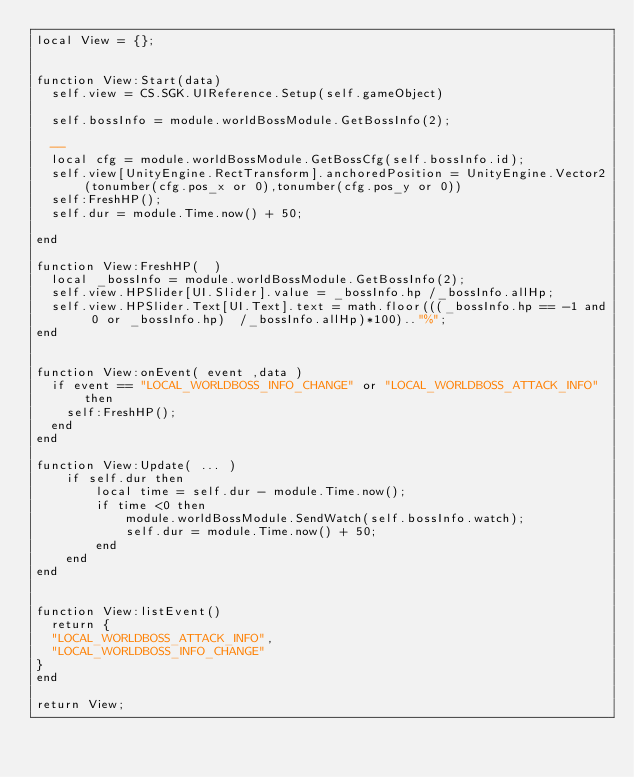Convert code to text. <code><loc_0><loc_0><loc_500><loc_500><_Lua_>local View = {};


function View:Start(data)
	self.view = CS.SGK.UIReference.Setup(self.gameObject)

	self.bossInfo = module.worldBossModule.GetBossInfo(2);

	-- 
	local cfg = module.worldBossModule.GetBossCfg(self.bossInfo.id);
	self.view[UnityEngine.RectTransform].anchoredPosition = UnityEngine.Vector2(tonumber(cfg.pos_x or 0),tonumber(cfg.pos_y or 0))
	self:FreshHP();
	self.dur = module.Time.now() + 50;

end

function View:FreshHP(  )
	local _bossInfo = module.worldBossModule.GetBossInfo(2);
	self.view.HPSlider[UI.Slider].value = _bossInfo.hp /_bossInfo.allHp;
	self.view.HPSlider.Text[UI.Text].text = math.floor(((_bossInfo.hp == -1 and 0 or _bossInfo.hp)  /_bossInfo.allHp)*100).."%";
end


function View:onEvent( event ,data )
	if event == "LOCAL_WORLDBOSS_INFO_CHANGE" or "LOCAL_WORLDBOSS_ATTACK_INFO" then
		self:FreshHP();
	end
end

function View:Update( ... )
    if self.dur then
        local time = self.dur - module.Time.now();
        if time <0 then
            module.worldBossModule.SendWatch(self.bossInfo.watch);
            self.dur = module.Time.now() + 50;
        end
    end
end


function View:listEvent()
	return {
	"LOCAL_WORLDBOSS_ATTACK_INFO",
	"LOCAL_WORLDBOSS_INFO_CHANGE"
}
end

return View;</code> 